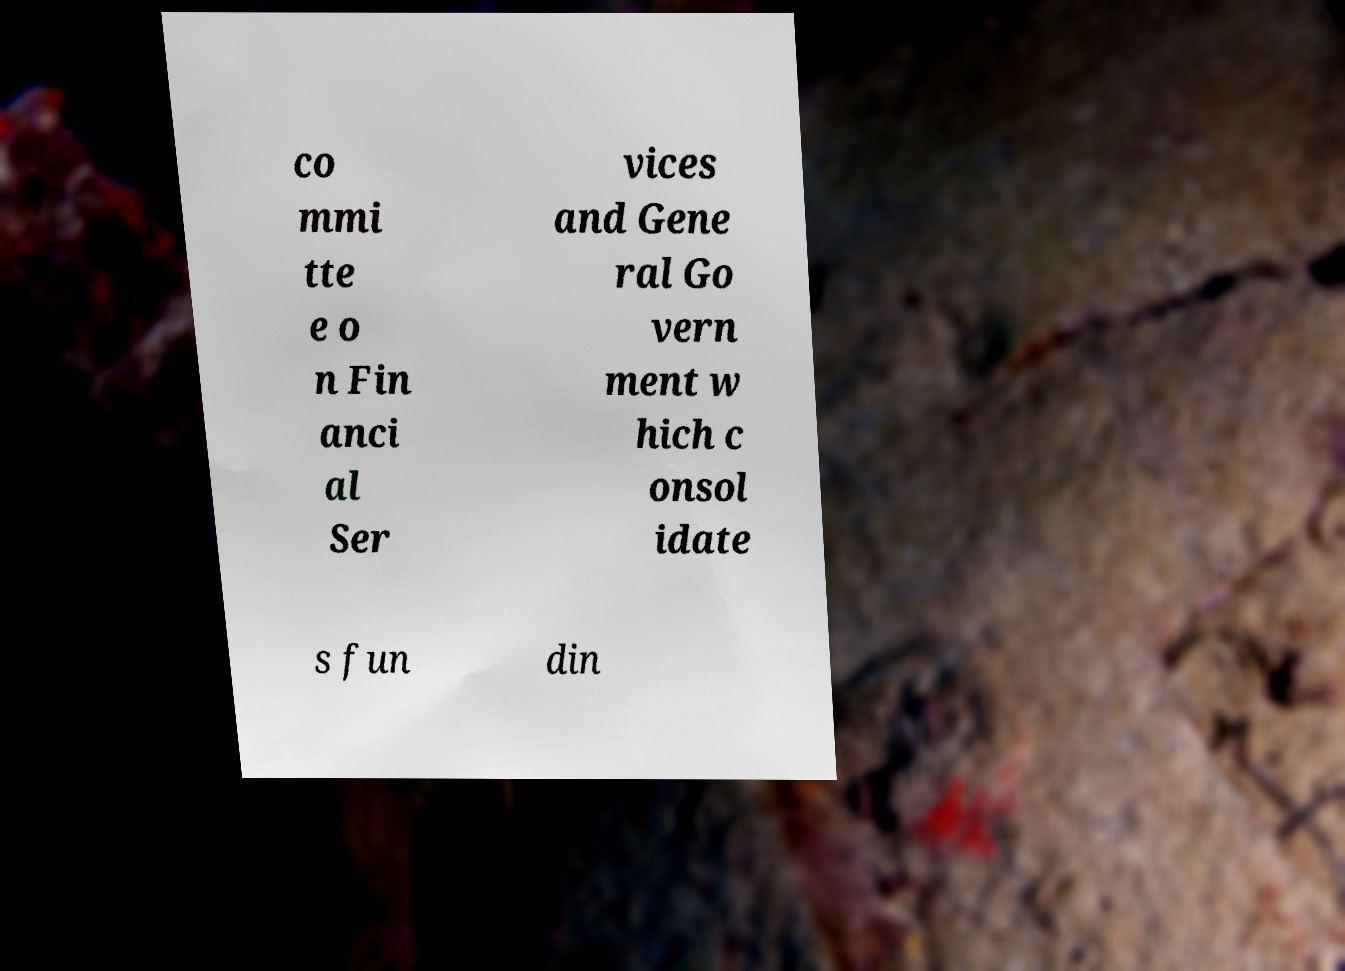What messages or text are displayed in this image? I need them in a readable, typed format. co mmi tte e o n Fin anci al Ser vices and Gene ral Go vern ment w hich c onsol idate s fun din 